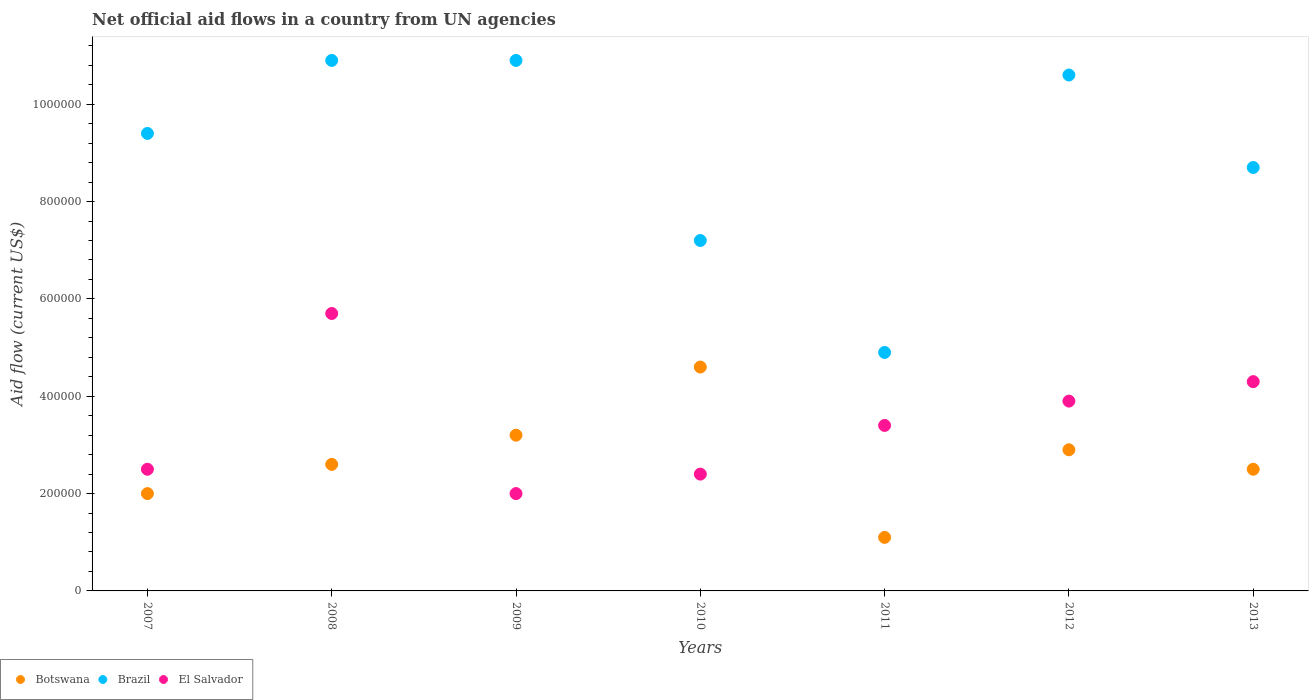How many different coloured dotlines are there?
Your response must be concise. 3. What is the net official aid flow in Botswana in 2013?
Ensure brevity in your answer.  2.50e+05. Across all years, what is the maximum net official aid flow in Brazil?
Ensure brevity in your answer.  1.09e+06. Across all years, what is the minimum net official aid flow in El Salvador?
Keep it short and to the point. 2.00e+05. In which year was the net official aid flow in El Salvador maximum?
Your answer should be very brief. 2008. In which year was the net official aid flow in El Salvador minimum?
Ensure brevity in your answer.  2009. What is the total net official aid flow in Brazil in the graph?
Keep it short and to the point. 6.26e+06. What is the difference between the net official aid flow in Botswana in 2010 and that in 2012?
Your answer should be compact. 1.70e+05. What is the difference between the net official aid flow in Botswana in 2013 and the net official aid flow in El Salvador in 2007?
Your response must be concise. 0. What is the average net official aid flow in Botswana per year?
Your answer should be compact. 2.70e+05. In the year 2012, what is the difference between the net official aid flow in Brazil and net official aid flow in El Salvador?
Provide a short and direct response. 6.70e+05. What is the ratio of the net official aid flow in El Salvador in 2009 to that in 2010?
Offer a very short reply. 0.83. Is the net official aid flow in Brazil in 2007 less than that in 2008?
Your response must be concise. Yes. What is the difference between the highest and the second highest net official aid flow in Botswana?
Provide a succinct answer. 1.40e+05. What is the difference between the highest and the lowest net official aid flow in Brazil?
Offer a very short reply. 6.00e+05. Is the sum of the net official aid flow in Botswana in 2007 and 2012 greater than the maximum net official aid flow in Brazil across all years?
Offer a very short reply. No. Does the net official aid flow in El Salvador monotonically increase over the years?
Your answer should be very brief. No. Is the net official aid flow in Botswana strictly less than the net official aid flow in Brazil over the years?
Offer a terse response. Yes. How many dotlines are there?
Your response must be concise. 3. How many years are there in the graph?
Your answer should be compact. 7. Does the graph contain grids?
Keep it short and to the point. No. What is the title of the graph?
Offer a terse response. Net official aid flows in a country from UN agencies. What is the label or title of the Y-axis?
Ensure brevity in your answer.  Aid flow (current US$). What is the Aid flow (current US$) of Botswana in 2007?
Keep it short and to the point. 2.00e+05. What is the Aid flow (current US$) in Brazil in 2007?
Provide a short and direct response. 9.40e+05. What is the Aid flow (current US$) in Botswana in 2008?
Your answer should be very brief. 2.60e+05. What is the Aid flow (current US$) in Brazil in 2008?
Keep it short and to the point. 1.09e+06. What is the Aid flow (current US$) in El Salvador in 2008?
Offer a very short reply. 5.70e+05. What is the Aid flow (current US$) in Brazil in 2009?
Ensure brevity in your answer.  1.09e+06. What is the Aid flow (current US$) in El Salvador in 2009?
Give a very brief answer. 2.00e+05. What is the Aid flow (current US$) of Botswana in 2010?
Make the answer very short. 4.60e+05. What is the Aid flow (current US$) in Brazil in 2010?
Ensure brevity in your answer.  7.20e+05. What is the Aid flow (current US$) of Botswana in 2011?
Your answer should be very brief. 1.10e+05. What is the Aid flow (current US$) in Brazil in 2012?
Make the answer very short. 1.06e+06. What is the Aid flow (current US$) in El Salvador in 2012?
Your response must be concise. 3.90e+05. What is the Aid flow (current US$) of Brazil in 2013?
Make the answer very short. 8.70e+05. What is the Aid flow (current US$) in El Salvador in 2013?
Give a very brief answer. 4.30e+05. Across all years, what is the maximum Aid flow (current US$) in Botswana?
Give a very brief answer. 4.60e+05. Across all years, what is the maximum Aid flow (current US$) in Brazil?
Ensure brevity in your answer.  1.09e+06. Across all years, what is the maximum Aid flow (current US$) of El Salvador?
Your answer should be very brief. 5.70e+05. What is the total Aid flow (current US$) in Botswana in the graph?
Ensure brevity in your answer.  1.89e+06. What is the total Aid flow (current US$) in Brazil in the graph?
Ensure brevity in your answer.  6.26e+06. What is the total Aid flow (current US$) of El Salvador in the graph?
Provide a succinct answer. 2.42e+06. What is the difference between the Aid flow (current US$) in Botswana in 2007 and that in 2008?
Your answer should be compact. -6.00e+04. What is the difference between the Aid flow (current US$) in Brazil in 2007 and that in 2008?
Offer a very short reply. -1.50e+05. What is the difference between the Aid flow (current US$) in El Salvador in 2007 and that in 2008?
Make the answer very short. -3.20e+05. What is the difference between the Aid flow (current US$) of Brazil in 2007 and that in 2009?
Give a very brief answer. -1.50e+05. What is the difference between the Aid flow (current US$) in Botswana in 2007 and that in 2010?
Your answer should be compact. -2.60e+05. What is the difference between the Aid flow (current US$) in El Salvador in 2007 and that in 2011?
Your answer should be very brief. -9.00e+04. What is the difference between the Aid flow (current US$) of Botswana in 2007 and that in 2012?
Your answer should be very brief. -9.00e+04. What is the difference between the Aid flow (current US$) in El Salvador in 2007 and that in 2013?
Keep it short and to the point. -1.80e+05. What is the difference between the Aid flow (current US$) of Botswana in 2008 and that in 2010?
Give a very brief answer. -2.00e+05. What is the difference between the Aid flow (current US$) in Botswana in 2008 and that in 2012?
Keep it short and to the point. -3.00e+04. What is the difference between the Aid flow (current US$) of Botswana in 2008 and that in 2013?
Your answer should be very brief. 10000. What is the difference between the Aid flow (current US$) of Botswana in 2009 and that in 2010?
Ensure brevity in your answer.  -1.40e+05. What is the difference between the Aid flow (current US$) in Brazil in 2009 and that in 2010?
Give a very brief answer. 3.70e+05. What is the difference between the Aid flow (current US$) in El Salvador in 2009 and that in 2010?
Provide a short and direct response. -4.00e+04. What is the difference between the Aid flow (current US$) in Botswana in 2009 and that in 2011?
Keep it short and to the point. 2.10e+05. What is the difference between the Aid flow (current US$) in El Salvador in 2009 and that in 2011?
Give a very brief answer. -1.40e+05. What is the difference between the Aid flow (current US$) in Botswana in 2009 and that in 2012?
Keep it short and to the point. 3.00e+04. What is the difference between the Aid flow (current US$) of Brazil in 2009 and that in 2012?
Offer a very short reply. 3.00e+04. What is the difference between the Aid flow (current US$) of El Salvador in 2009 and that in 2012?
Make the answer very short. -1.90e+05. What is the difference between the Aid flow (current US$) of Brazil in 2009 and that in 2013?
Your answer should be compact. 2.20e+05. What is the difference between the Aid flow (current US$) of El Salvador in 2009 and that in 2013?
Provide a succinct answer. -2.30e+05. What is the difference between the Aid flow (current US$) of Brazil in 2010 and that in 2011?
Your answer should be very brief. 2.30e+05. What is the difference between the Aid flow (current US$) of El Salvador in 2010 and that in 2011?
Keep it short and to the point. -1.00e+05. What is the difference between the Aid flow (current US$) of Botswana in 2010 and that in 2012?
Your answer should be compact. 1.70e+05. What is the difference between the Aid flow (current US$) of El Salvador in 2010 and that in 2012?
Provide a short and direct response. -1.50e+05. What is the difference between the Aid flow (current US$) in Brazil in 2010 and that in 2013?
Your answer should be compact. -1.50e+05. What is the difference between the Aid flow (current US$) in El Salvador in 2010 and that in 2013?
Give a very brief answer. -1.90e+05. What is the difference between the Aid flow (current US$) in Botswana in 2011 and that in 2012?
Ensure brevity in your answer.  -1.80e+05. What is the difference between the Aid flow (current US$) of Brazil in 2011 and that in 2012?
Provide a short and direct response. -5.70e+05. What is the difference between the Aid flow (current US$) in El Salvador in 2011 and that in 2012?
Your response must be concise. -5.00e+04. What is the difference between the Aid flow (current US$) in Botswana in 2011 and that in 2013?
Your answer should be very brief. -1.40e+05. What is the difference between the Aid flow (current US$) in Brazil in 2011 and that in 2013?
Offer a terse response. -3.80e+05. What is the difference between the Aid flow (current US$) in Botswana in 2012 and that in 2013?
Make the answer very short. 4.00e+04. What is the difference between the Aid flow (current US$) of Brazil in 2012 and that in 2013?
Keep it short and to the point. 1.90e+05. What is the difference between the Aid flow (current US$) of El Salvador in 2012 and that in 2013?
Offer a terse response. -4.00e+04. What is the difference between the Aid flow (current US$) of Botswana in 2007 and the Aid flow (current US$) of Brazil in 2008?
Your response must be concise. -8.90e+05. What is the difference between the Aid flow (current US$) in Botswana in 2007 and the Aid flow (current US$) in El Salvador in 2008?
Ensure brevity in your answer.  -3.70e+05. What is the difference between the Aid flow (current US$) of Brazil in 2007 and the Aid flow (current US$) of El Salvador in 2008?
Your response must be concise. 3.70e+05. What is the difference between the Aid flow (current US$) in Botswana in 2007 and the Aid flow (current US$) in Brazil in 2009?
Your answer should be compact. -8.90e+05. What is the difference between the Aid flow (current US$) in Botswana in 2007 and the Aid flow (current US$) in El Salvador in 2009?
Make the answer very short. 0. What is the difference between the Aid flow (current US$) in Brazil in 2007 and the Aid flow (current US$) in El Salvador in 2009?
Provide a succinct answer. 7.40e+05. What is the difference between the Aid flow (current US$) of Botswana in 2007 and the Aid flow (current US$) of Brazil in 2010?
Your response must be concise. -5.20e+05. What is the difference between the Aid flow (current US$) in Botswana in 2007 and the Aid flow (current US$) in El Salvador in 2010?
Keep it short and to the point. -4.00e+04. What is the difference between the Aid flow (current US$) of Brazil in 2007 and the Aid flow (current US$) of El Salvador in 2011?
Offer a very short reply. 6.00e+05. What is the difference between the Aid flow (current US$) of Botswana in 2007 and the Aid flow (current US$) of Brazil in 2012?
Offer a terse response. -8.60e+05. What is the difference between the Aid flow (current US$) in Botswana in 2007 and the Aid flow (current US$) in El Salvador in 2012?
Provide a short and direct response. -1.90e+05. What is the difference between the Aid flow (current US$) of Brazil in 2007 and the Aid flow (current US$) of El Salvador in 2012?
Keep it short and to the point. 5.50e+05. What is the difference between the Aid flow (current US$) of Botswana in 2007 and the Aid flow (current US$) of Brazil in 2013?
Provide a succinct answer. -6.70e+05. What is the difference between the Aid flow (current US$) in Brazil in 2007 and the Aid flow (current US$) in El Salvador in 2013?
Ensure brevity in your answer.  5.10e+05. What is the difference between the Aid flow (current US$) of Botswana in 2008 and the Aid flow (current US$) of Brazil in 2009?
Give a very brief answer. -8.30e+05. What is the difference between the Aid flow (current US$) in Brazil in 2008 and the Aid flow (current US$) in El Salvador in 2009?
Provide a short and direct response. 8.90e+05. What is the difference between the Aid flow (current US$) in Botswana in 2008 and the Aid flow (current US$) in Brazil in 2010?
Provide a succinct answer. -4.60e+05. What is the difference between the Aid flow (current US$) of Botswana in 2008 and the Aid flow (current US$) of El Salvador in 2010?
Provide a short and direct response. 2.00e+04. What is the difference between the Aid flow (current US$) of Brazil in 2008 and the Aid flow (current US$) of El Salvador in 2010?
Provide a succinct answer. 8.50e+05. What is the difference between the Aid flow (current US$) in Botswana in 2008 and the Aid flow (current US$) in El Salvador in 2011?
Ensure brevity in your answer.  -8.00e+04. What is the difference between the Aid flow (current US$) in Brazil in 2008 and the Aid flow (current US$) in El Salvador in 2011?
Keep it short and to the point. 7.50e+05. What is the difference between the Aid flow (current US$) in Botswana in 2008 and the Aid flow (current US$) in Brazil in 2012?
Keep it short and to the point. -8.00e+05. What is the difference between the Aid flow (current US$) of Botswana in 2008 and the Aid flow (current US$) of Brazil in 2013?
Your answer should be compact. -6.10e+05. What is the difference between the Aid flow (current US$) in Brazil in 2008 and the Aid flow (current US$) in El Salvador in 2013?
Make the answer very short. 6.60e+05. What is the difference between the Aid flow (current US$) of Botswana in 2009 and the Aid flow (current US$) of Brazil in 2010?
Keep it short and to the point. -4.00e+05. What is the difference between the Aid flow (current US$) of Botswana in 2009 and the Aid flow (current US$) of El Salvador in 2010?
Keep it short and to the point. 8.00e+04. What is the difference between the Aid flow (current US$) of Brazil in 2009 and the Aid flow (current US$) of El Salvador in 2010?
Give a very brief answer. 8.50e+05. What is the difference between the Aid flow (current US$) of Botswana in 2009 and the Aid flow (current US$) of Brazil in 2011?
Keep it short and to the point. -1.70e+05. What is the difference between the Aid flow (current US$) in Brazil in 2009 and the Aid flow (current US$) in El Salvador in 2011?
Offer a very short reply. 7.50e+05. What is the difference between the Aid flow (current US$) in Botswana in 2009 and the Aid flow (current US$) in Brazil in 2012?
Keep it short and to the point. -7.40e+05. What is the difference between the Aid flow (current US$) of Botswana in 2009 and the Aid flow (current US$) of Brazil in 2013?
Keep it short and to the point. -5.50e+05. What is the difference between the Aid flow (current US$) in Brazil in 2010 and the Aid flow (current US$) in El Salvador in 2011?
Keep it short and to the point. 3.80e+05. What is the difference between the Aid flow (current US$) in Botswana in 2010 and the Aid flow (current US$) in Brazil in 2012?
Keep it short and to the point. -6.00e+05. What is the difference between the Aid flow (current US$) in Brazil in 2010 and the Aid flow (current US$) in El Salvador in 2012?
Give a very brief answer. 3.30e+05. What is the difference between the Aid flow (current US$) in Botswana in 2010 and the Aid flow (current US$) in Brazil in 2013?
Your answer should be compact. -4.10e+05. What is the difference between the Aid flow (current US$) of Botswana in 2010 and the Aid flow (current US$) of El Salvador in 2013?
Provide a short and direct response. 3.00e+04. What is the difference between the Aid flow (current US$) of Brazil in 2010 and the Aid flow (current US$) of El Salvador in 2013?
Offer a very short reply. 2.90e+05. What is the difference between the Aid flow (current US$) of Botswana in 2011 and the Aid flow (current US$) of Brazil in 2012?
Your answer should be very brief. -9.50e+05. What is the difference between the Aid flow (current US$) in Botswana in 2011 and the Aid flow (current US$) in El Salvador in 2012?
Your answer should be compact. -2.80e+05. What is the difference between the Aid flow (current US$) of Brazil in 2011 and the Aid flow (current US$) of El Salvador in 2012?
Your answer should be compact. 1.00e+05. What is the difference between the Aid flow (current US$) in Botswana in 2011 and the Aid flow (current US$) in Brazil in 2013?
Your answer should be very brief. -7.60e+05. What is the difference between the Aid flow (current US$) in Botswana in 2011 and the Aid flow (current US$) in El Salvador in 2013?
Give a very brief answer. -3.20e+05. What is the difference between the Aid flow (current US$) of Botswana in 2012 and the Aid flow (current US$) of Brazil in 2013?
Offer a terse response. -5.80e+05. What is the difference between the Aid flow (current US$) of Botswana in 2012 and the Aid flow (current US$) of El Salvador in 2013?
Your response must be concise. -1.40e+05. What is the difference between the Aid flow (current US$) in Brazil in 2012 and the Aid flow (current US$) in El Salvador in 2013?
Your answer should be compact. 6.30e+05. What is the average Aid flow (current US$) in Brazil per year?
Your answer should be very brief. 8.94e+05. What is the average Aid flow (current US$) of El Salvador per year?
Offer a terse response. 3.46e+05. In the year 2007, what is the difference between the Aid flow (current US$) of Botswana and Aid flow (current US$) of Brazil?
Provide a short and direct response. -7.40e+05. In the year 2007, what is the difference between the Aid flow (current US$) of Botswana and Aid flow (current US$) of El Salvador?
Provide a short and direct response. -5.00e+04. In the year 2007, what is the difference between the Aid flow (current US$) in Brazil and Aid flow (current US$) in El Salvador?
Give a very brief answer. 6.90e+05. In the year 2008, what is the difference between the Aid flow (current US$) of Botswana and Aid flow (current US$) of Brazil?
Your answer should be very brief. -8.30e+05. In the year 2008, what is the difference between the Aid flow (current US$) in Botswana and Aid flow (current US$) in El Salvador?
Offer a very short reply. -3.10e+05. In the year 2008, what is the difference between the Aid flow (current US$) of Brazil and Aid flow (current US$) of El Salvador?
Offer a terse response. 5.20e+05. In the year 2009, what is the difference between the Aid flow (current US$) of Botswana and Aid flow (current US$) of Brazil?
Ensure brevity in your answer.  -7.70e+05. In the year 2009, what is the difference between the Aid flow (current US$) in Botswana and Aid flow (current US$) in El Salvador?
Provide a succinct answer. 1.20e+05. In the year 2009, what is the difference between the Aid flow (current US$) of Brazil and Aid flow (current US$) of El Salvador?
Make the answer very short. 8.90e+05. In the year 2010, what is the difference between the Aid flow (current US$) of Botswana and Aid flow (current US$) of El Salvador?
Offer a very short reply. 2.20e+05. In the year 2011, what is the difference between the Aid flow (current US$) in Botswana and Aid flow (current US$) in Brazil?
Your answer should be very brief. -3.80e+05. In the year 2011, what is the difference between the Aid flow (current US$) of Botswana and Aid flow (current US$) of El Salvador?
Give a very brief answer. -2.30e+05. In the year 2012, what is the difference between the Aid flow (current US$) of Botswana and Aid flow (current US$) of Brazil?
Offer a terse response. -7.70e+05. In the year 2012, what is the difference between the Aid flow (current US$) of Brazil and Aid flow (current US$) of El Salvador?
Provide a succinct answer. 6.70e+05. In the year 2013, what is the difference between the Aid flow (current US$) of Botswana and Aid flow (current US$) of Brazil?
Your answer should be very brief. -6.20e+05. What is the ratio of the Aid flow (current US$) of Botswana in 2007 to that in 2008?
Give a very brief answer. 0.77. What is the ratio of the Aid flow (current US$) in Brazil in 2007 to that in 2008?
Your response must be concise. 0.86. What is the ratio of the Aid flow (current US$) of El Salvador in 2007 to that in 2008?
Offer a terse response. 0.44. What is the ratio of the Aid flow (current US$) of Botswana in 2007 to that in 2009?
Your response must be concise. 0.62. What is the ratio of the Aid flow (current US$) of Brazil in 2007 to that in 2009?
Give a very brief answer. 0.86. What is the ratio of the Aid flow (current US$) of Botswana in 2007 to that in 2010?
Provide a succinct answer. 0.43. What is the ratio of the Aid flow (current US$) in Brazil in 2007 to that in 2010?
Ensure brevity in your answer.  1.31. What is the ratio of the Aid flow (current US$) in El Salvador in 2007 to that in 2010?
Keep it short and to the point. 1.04. What is the ratio of the Aid flow (current US$) of Botswana in 2007 to that in 2011?
Your answer should be very brief. 1.82. What is the ratio of the Aid flow (current US$) in Brazil in 2007 to that in 2011?
Your answer should be compact. 1.92. What is the ratio of the Aid flow (current US$) in El Salvador in 2007 to that in 2011?
Give a very brief answer. 0.74. What is the ratio of the Aid flow (current US$) in Botswana in 2007 to that in 2012?
Your answer should be very brief. 0.69. What is the ratio of the Aid flow (current US$) of Brazil in 2007 to that in 2012?
Provide a succinct answer. 0.89. What is the ratio of the Aid flow (current US$) in El Salvador in 2007 to that in 2012?
Provide a short and direct response. 0.64. What is the ratio of the Aid flow (current US$) in Brazil in 2007 to that in 2013?
Make the answer very short. 1.08. What is the ratio of the Aid flow (current US$) in El Salvador in 2007 to that in 2013?
Give a very brief answer. 0.58. What is the ratio of the Aid flow (current US$) in Botswana in 2008 to that in 2009?
Ensure brevity in your answer.  0.81. What is the ratio of the Aid flow (current US$) of El Salvador in 2008 to that in 2009?
Keep it short and to the point. 2.85. What is the ratio of the Aid flow (current US$) of Botswana in 2008 to that in 2010?
Your response must be concise. 0.57. What is the ratio of the Aid flow (current US$) in Brazil in 2008 to that in 2010?
Offer a very short reply. 1.51. What is the ratio of the Aid flow (current US$) of El Salvador in 2008 to that in 2010?
Your response must be concise. 2.38. What is the ratio of the Aid flow (current US$) of Botswana in 2008 to that in 2011?
Your answer should be very brief. 2.36. What is the ratio of the Aid flow (current US$) of Brazil in 2008 to that in 2011?
Your answer should be very brief. 2.22. What is the ratio of the Aid flow (current US$) of El Salvador in 2008 to that in 2011?
Your response must be concise. 1.68. What is the ratio of the Aid flow (current US$) of Botswana in 2008 to that in 2012?
Provide a succinct answer. 0.9. What is the ratio of the Aid flow (current US$) of Brazil in 2008 to that in 2012?
Keep it short and to the point. 1.03. What is the ratio of the Aid flow (current US$) of El Salvador in 2008 to that in 2012?
Keep it short and to the point. 1.46. What is the ratio of the Aid flow (current US$) of Botswana in 2008 to that in 2013?
Provide a succinct answer. 1.04. What is the ratio of the Aid flow (current US$) of Brazil in 2008 to that in 2013?
Offer a terse response. 1.25. What is the ratio of the Aid flow (current US$) of El Salvador in 2008 to that in 2013?
Your response must be concise. 1.33. What is the ratio of the Aid flow (current US$) of Botswana in 2009 to that in 2010?
Ensure brevity in your answer.  0.7. What is the ratio of the Aid flow (current US$) of Brazil in 2009 to that in 2010?
Your answer should be very brief. 1.51. What is the ratio of the Aid flow (current US$) of Botswana in 2009 to that in 2011?
Give a very brief answer. 2.91. What is the ratio of the Aid flow (current US$) of Brazil in 2009 to that in 2011?
Make the answer very short. 2.22. What is the ratio of the Aid flow (current US$) of El Salvador in 2009 to that in 2011?
Keep it short and to the point. 0.59. What is the ratio of the Aid flow (current US$) in Botswana in 2009 to that in 2012?
Provide a succinct answer. 1.1. What is the ratio of the Aid flow (current US$) of Brazil in 2009 to that in 2012?
Your response must be concise. 1.03. What is the ratio of the Aid flow (current US$) in El Salvador in 2009 to that in 2012?
Ensure brevity in your answer.  0.51. What is the ratio of the Aid flow (current US$) of Botswana in 2009 to that in 2013?
Make the answer very short. 1.28. What is the ratio of the Aid flow (current US$) in Brazil in 2009 to that in 2013?
Provide a succinct answer. 1.25. What is the ratio of the Aid flow (current US$) in El Salvador in 2009 to that in 2013?
Ensure brevity in your answer.  0.47. What is the ratio of the Aid flow (current US$) of Botswana in 2010 to that in 2011?
Give a very brief answer. 4.18. What is the ratio of the Aid flow (current US$) of Brazil in 2010 to that in 2011?
Offer a very short reply. 1.47. What is the ratio of the Aid flow (current US$) in El Salvador in 2010 to that in 2011?
Provide a succinct answer. 0.71. What is the ratio of the Aid flow (current US$) in Botswana in 2010 to that in 2012?
Your answer should be very brief. 1.59. What is the ratio of the Aid flow (current US$) of Brazil in 2010 to that in 2012?
Ensure brevity in your answer.  0.68. What is the ratio of the Aid flow (current US$) in El Salvador in 2010 to that in 2012?
Offer a terse response. 0.62. What is the ratio of the Aid flow (current US$) in Botswana in 2010 to that in 2013?
Keep it short and to the point. 1.84. What is the ratio of the Aid flow (current US$) in Brazil in 2010 to that in 2013?
Keep it short and to the point. 0.83. What is the ratio of the Aid flow (current US$) in El Salvador in 2010 to that in 2013?
Provide a short and direct response. 0.56. What is the ratio of the Aid flow (current US$) in Botswana in 2011 to that in 2012?
Provide a short and direct response. 0.38. What is the ratio of the Aid flow (current US$) in Brazil in 2011 to that in 2012?
Your answer should be very brief. 0.46. What is the ratio of the Aid flow (current US$) of El Salvador in 2011 to that in 2012?
Provide a succinct answer. 0.87. What is the ratio of the Aid flow (current US$) in Botswana in 2011 to that in 2013?
Your answer should be compact. 0.44. What is the ratio of the Aid flow (current US$) in Brazil in 2011 to that in 2013?
Provide a short and direct response. 0.56. What is the ratio of the Aid flow (current US$) of El Salvador in 2011 to that in 2013?
Give a very brief answer. 0.79. What is the ratio of the Aid flow (current US$) in Botswana in 2012 to that in 2013?
Provide a short and direct response. 1.16. What is the ratio of the Aid flow (current US$) in Brazil in 2012 to that in 2013?
Provide a short and direct response. 1.22. What is the ratio of the Aid flow (current US$) in El Salvador in 2012 to that in 2013?
Provide a short and direct response. 0.91. What is the difference between the highest and the second highest Aid flow (current US$) in Brazil?
Your answer should be compact. 0. What is the difference between the highest and the lowest Aid flow (current US$) of Botswana?
Your response must be concise. 3.50e+05. 